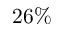<formula> <loc_0><loc_0><loc_500><loc_500>2 6 \%</formula> 